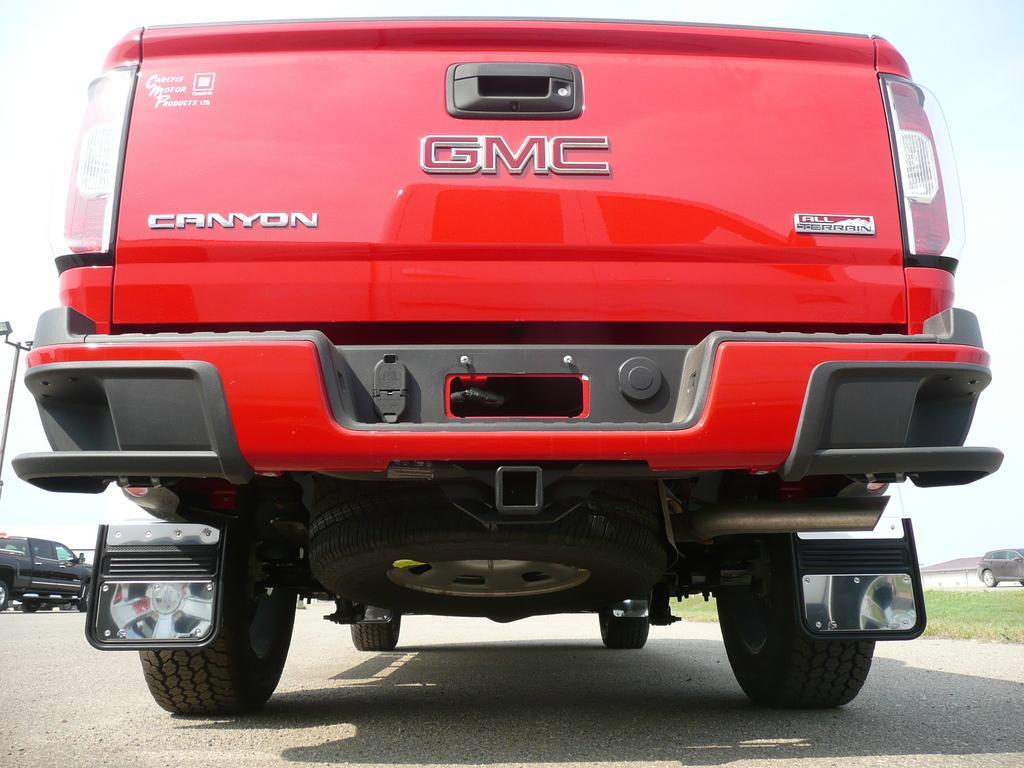In one or two sentences, can you explain what this image depicts? In this picture we can see a red color vehicle, on the left side there is a black color car, at the bottom there is grass, we can see a house and a car on the right side, there is the sky at the top of the picture, we can also see a pole on the left side. 